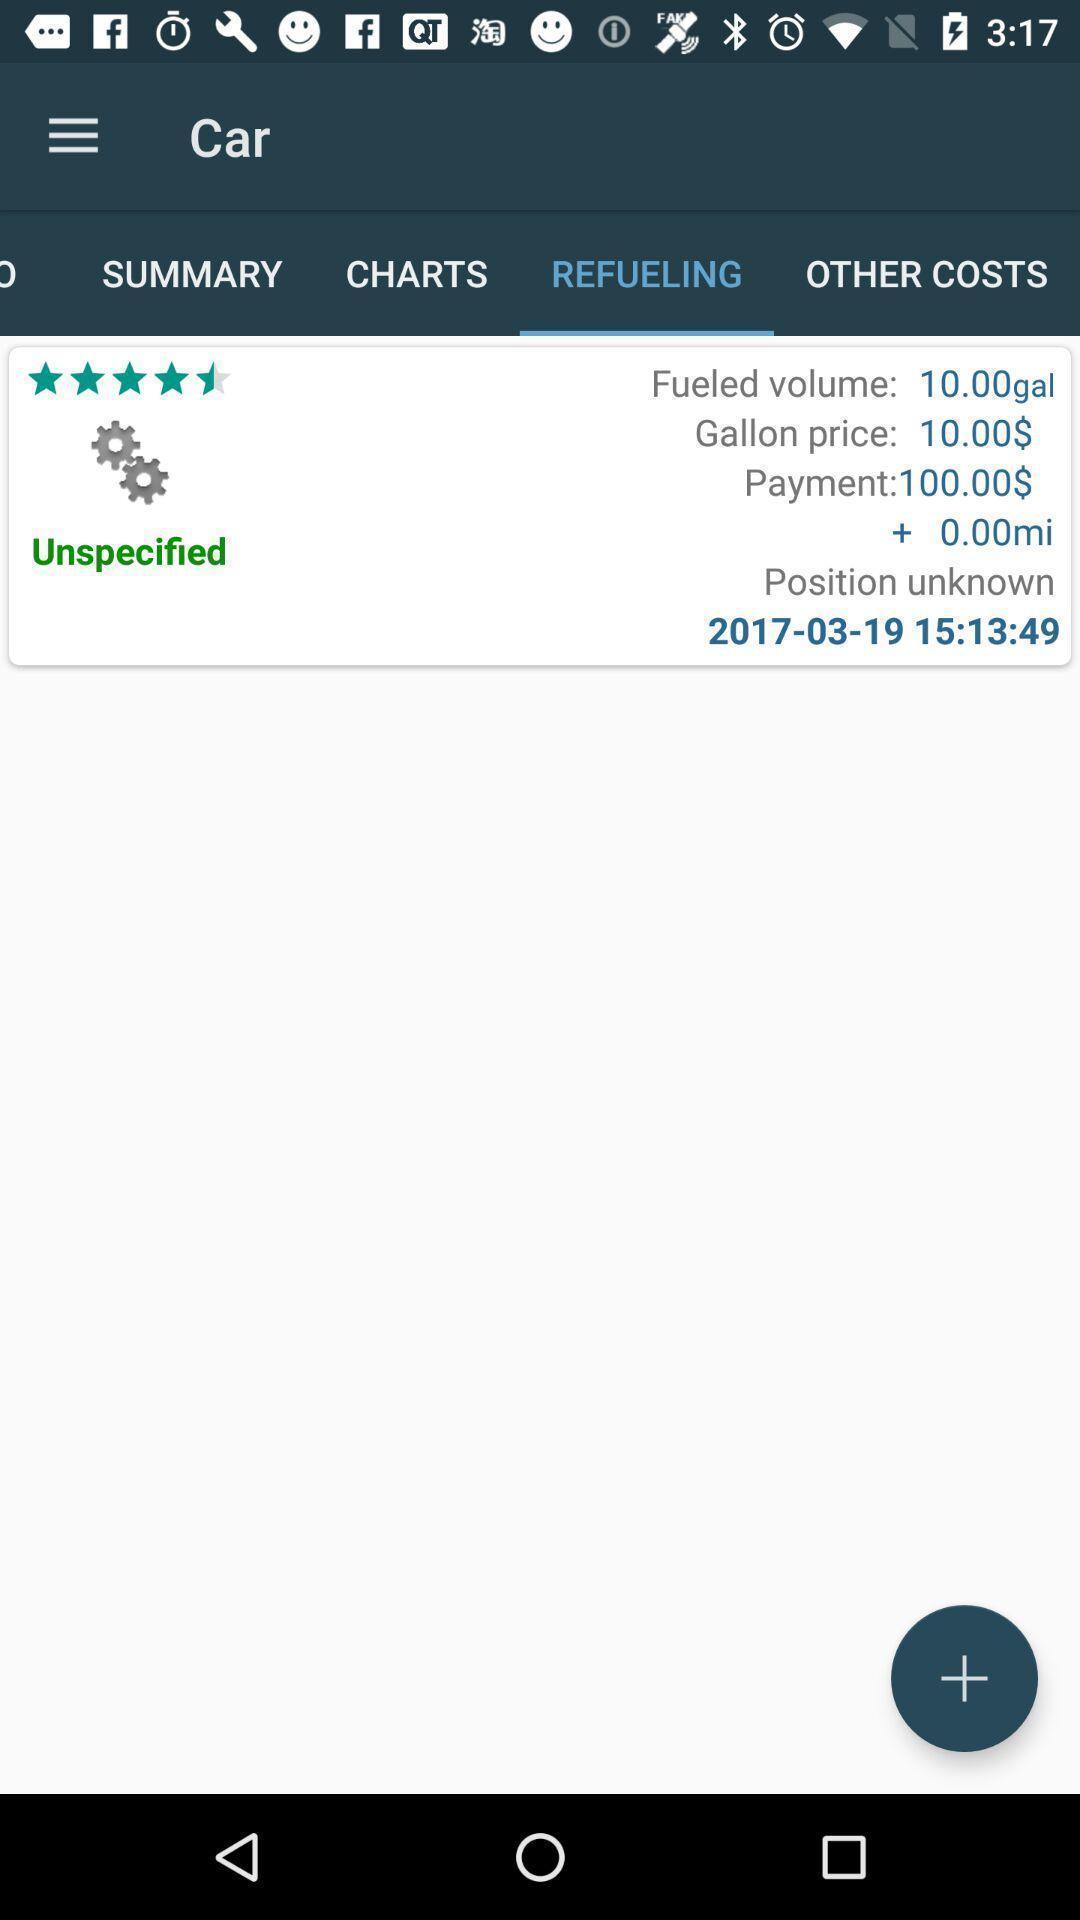Tell me what you see in this picture. Screen displaying fuel information about the vehicle. 